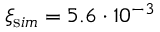Convert formula to latex. <formula><loc_0><loc_0><loc_500><loc_500>\xi _ { \mathrm s i m } = 5 . 6 \cdot 1 0 ^ { - 3 }</formula> 